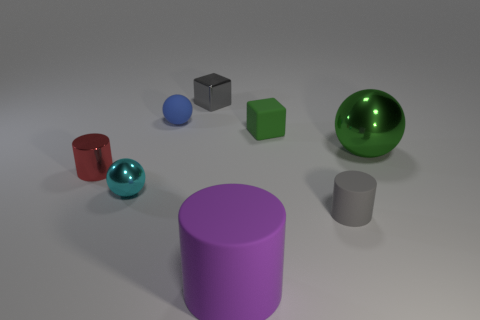How does the lighting affect the appearance of the objects? The lighting creates soft shadows and highlights the reflective qualities of the metallic and shiny objects, giving depth to the scene and emphasizing the textures and materials of the various objects. Which object seems to be the most reflective? The most reflective object is the shiny green sphere, which has a clear highlight and reflects the environment, indicating a glossy, possibly metallic or glass surface. 